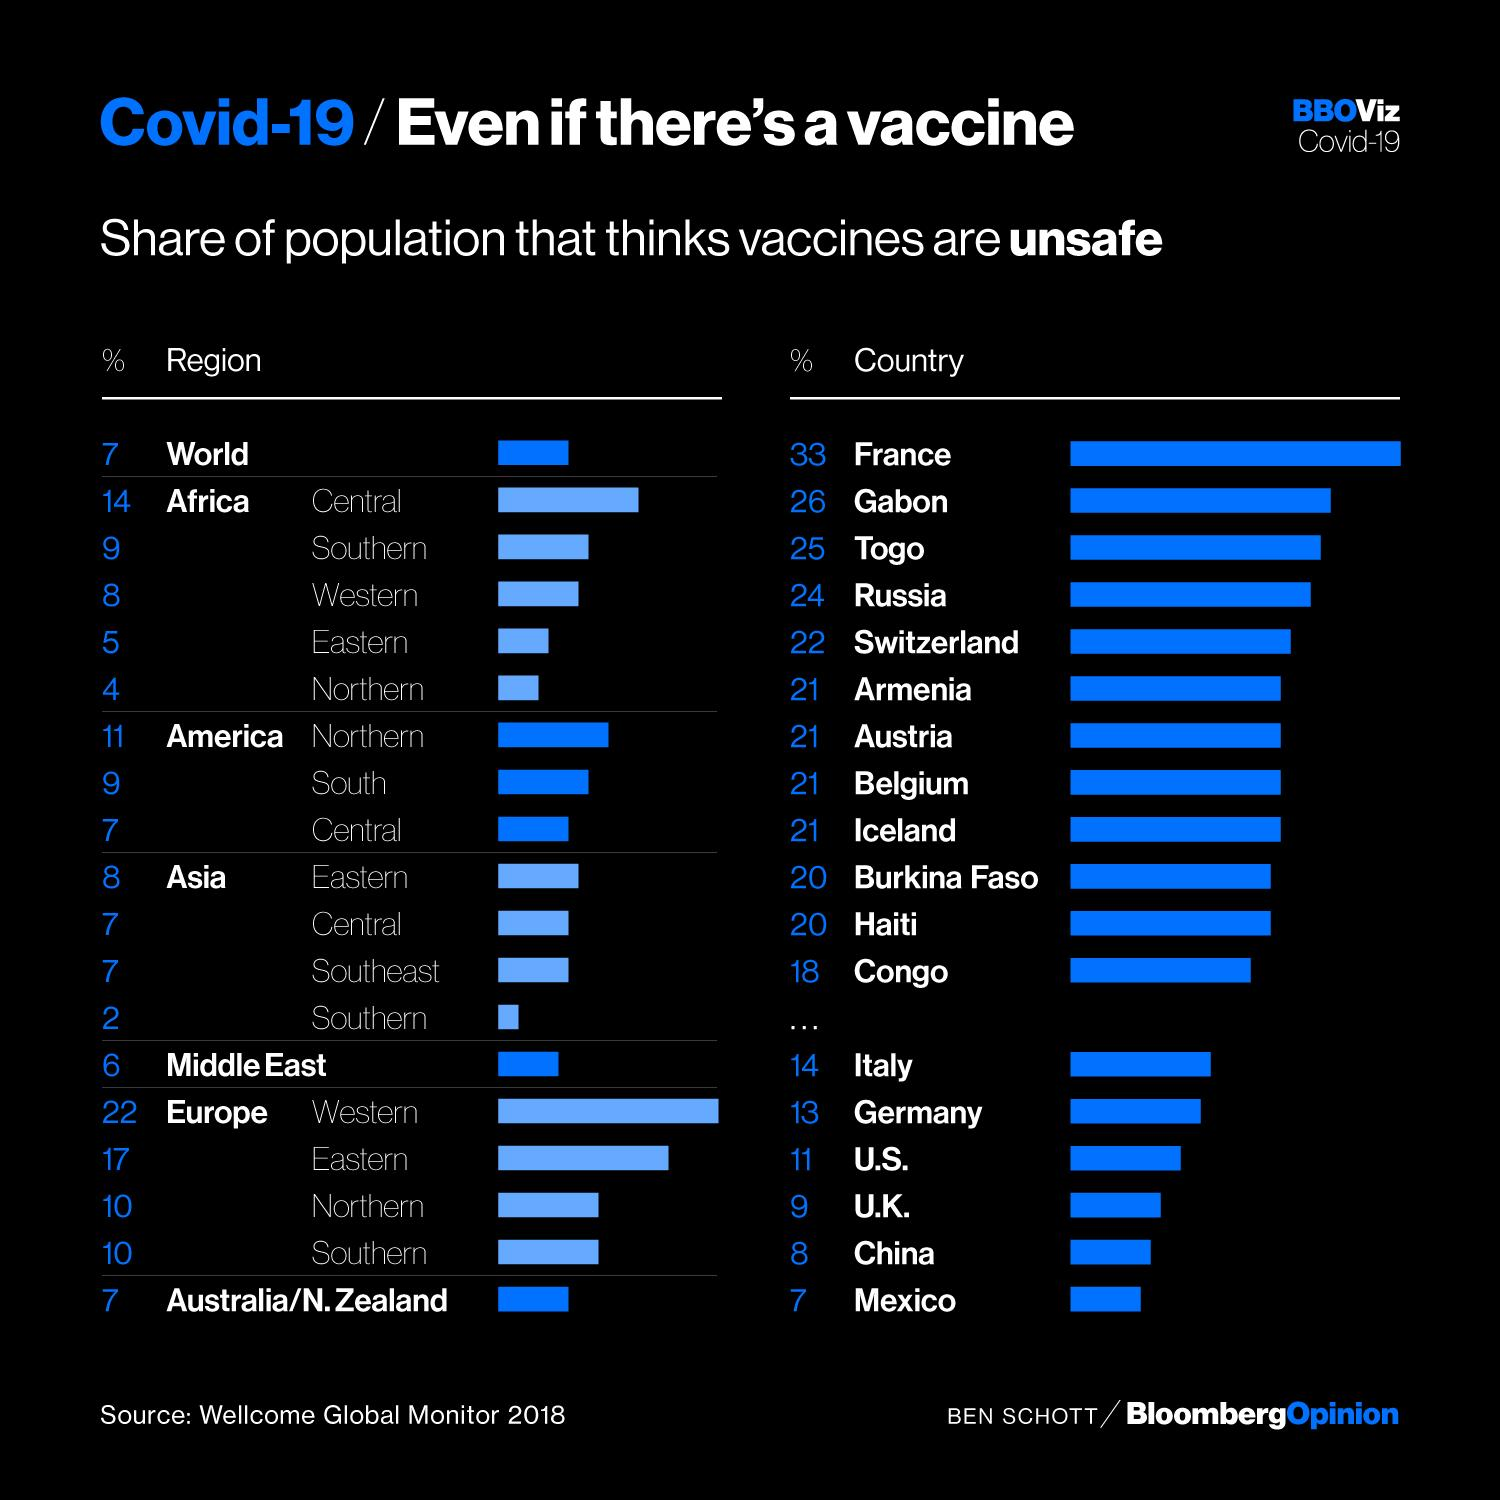Specify some key components in this picture. According to a recent survey, a significant percentage of the total population in Central and Southern Africa believe that vaccines are unsafe. Specifically, 23% of respondents held this belief. According to a recent survey, the country with the largest proportion of people who believe vaccines to be unsafe is France. In Burkina Faso, 20% of the population believe that vaccines are unsafe, a similar sentiment to that held by individuals in Haiti. According to a survey, the population of Mexico is found to be more trusting of vaccines than the Chinese population. The population of the southern part of Asia trusts vaccines more than the other parts of Asia, according to a recent survey. 